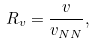<formula> <loc_0><loc_0><loc_500><loc_500>R _ { v } = \frac { v } { v _ { N N } } ,</formula> 